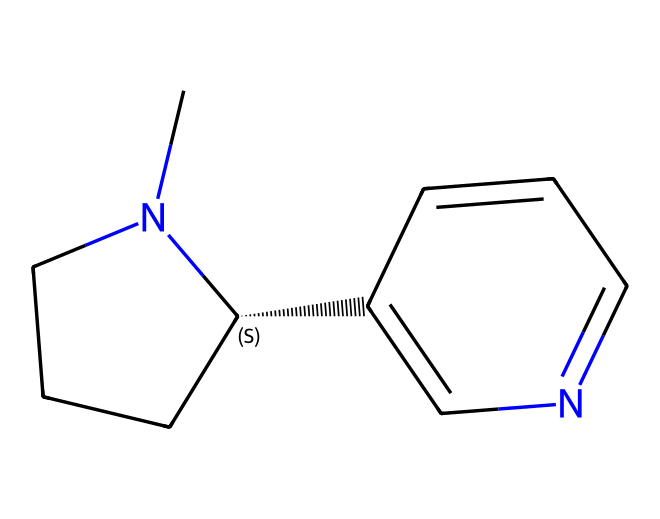How many carbon atoms are in the nicotine structure? By analyzing the SMILES representation, we count the number of carbon (C) symbols present. In this case, the representation shows a total of 10 carbon atoms.
Answer: 10 What is the functional group present in nicotine? The presence of the nitrogen atom indicates it belongs to the amine functional group, commonly found in many alkaloids including nicotine.
Answer: amine Is nicotine a cage compound? Yes, the structure exhibits features characteristic of cage compounds due to its cyclic structure among other atoms and rings present in its arrangement.
Answer: yes How many nitrogen atoms are present in nicotine? The SMILES representation includes two nitrogen (N) symbols, indicating there are two nitrogen atoms in the nicotine structure.
Answer: 2 What type of compound is nicotine classified as? Based on its structure and the presence of nitrogen, nicotine is classified as an alkaloid, which is a class of naturally occurring organic compounds.
Answer: alkaloid Does nicotine contain any double bonds? The structure includes a double bond in the ring, which can be identified by the connectivity of the carbon and nitrogen atoms; specifically, the nitrogen connected to two carbons indicates a double bond exists.
Answer: yes 